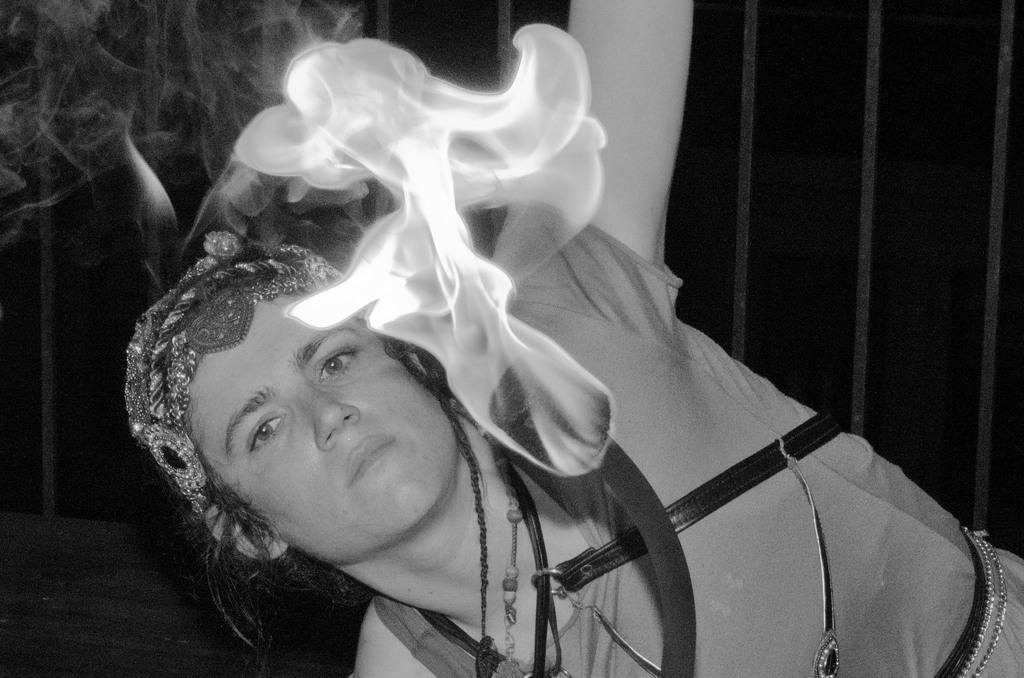Who is present in the image? There is a woman in the image. What event occurred in the image? A sponge caught fire in the image. What is the color scheme of the image? The image is in black and white color. What is the history of the playground in the image? There is no playground present in the image, so it is not possible to discuss its history. 